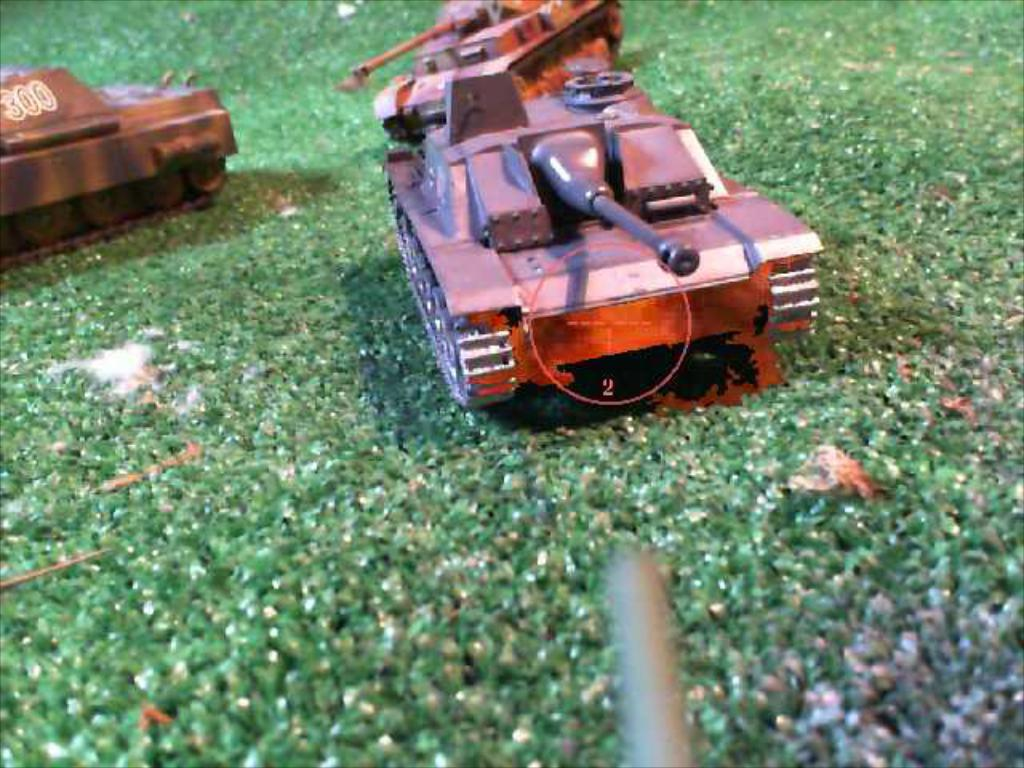What type of vehicles are in the image? There are Churchill tanks in the image. Where are the tanks located in the image? The tanks are in the center of the image. What type of terrain is visible at the bottom of the image? There is grass at the bottom of the image. What type of treatment is being administered to the man in the image? There is no man present in the image, and therefore no treatment can be observed. 